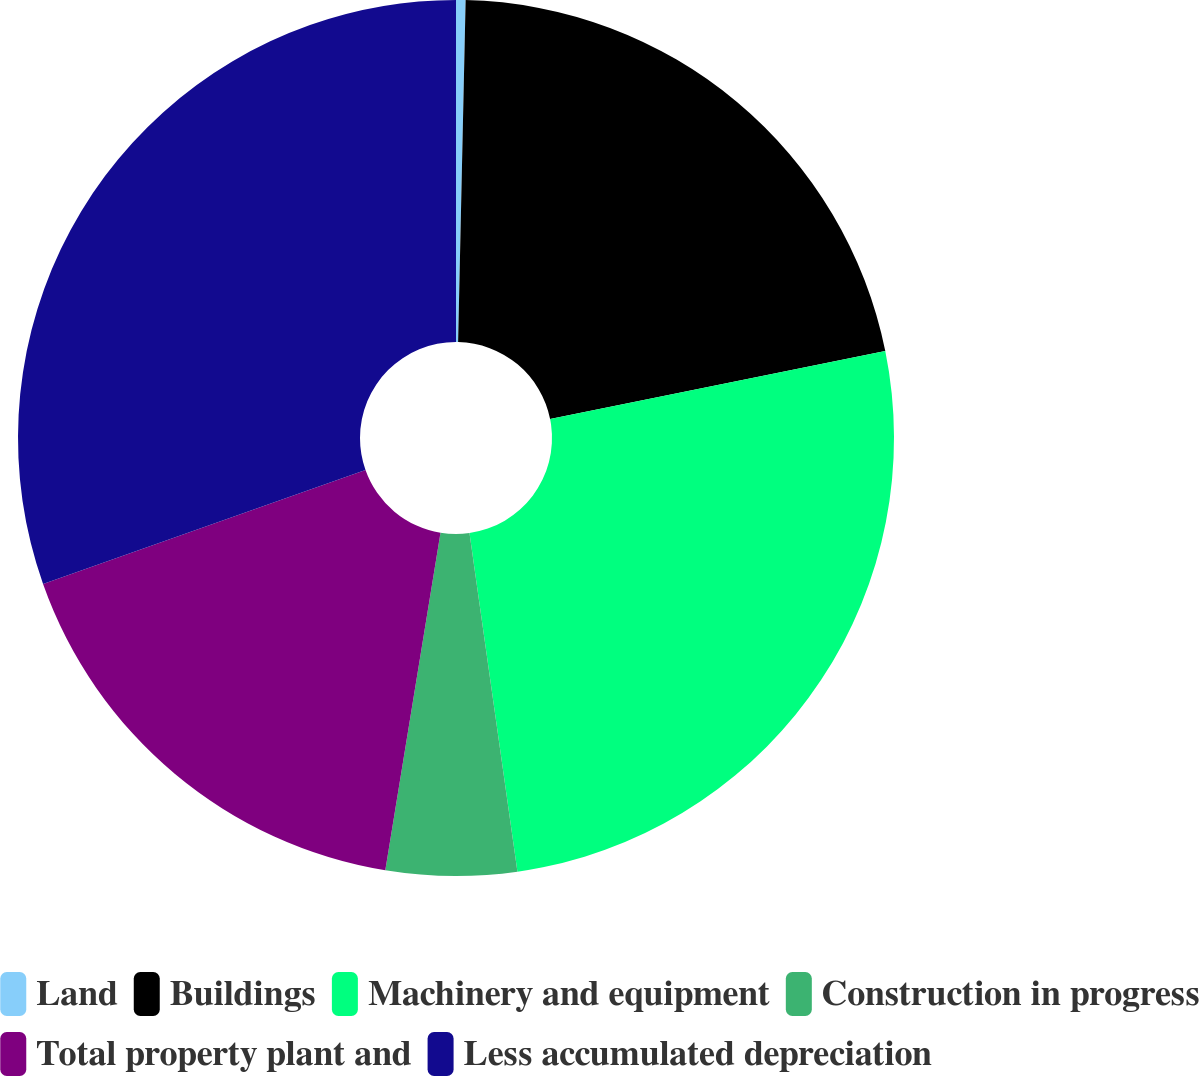<chart> <loc_0><loc_0><loc_500><loc_500><pie_chart><fcel>Land<fcel>Buildings<fcel>Machinery and equipment<fcel>Construction in progress<fcel>Total property plant and<fcel>Less accumulated depreciation<nl><fcel>0.35%<fcel>21.47%<fcel>25.94%<fcel>4.82%<fcel>17.01%<fcel>30.41%<nl></chart> 